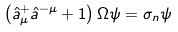Convert formula to latex. <formula><loc_0><loc_0><loc_500><loc_500>\left ( \hat { a } _ { \mu } ^ { + } \hat { a } ^ { - \mu } + 1 \right ) \Omega \psi = \sigma _ { n } \psi</formula> 